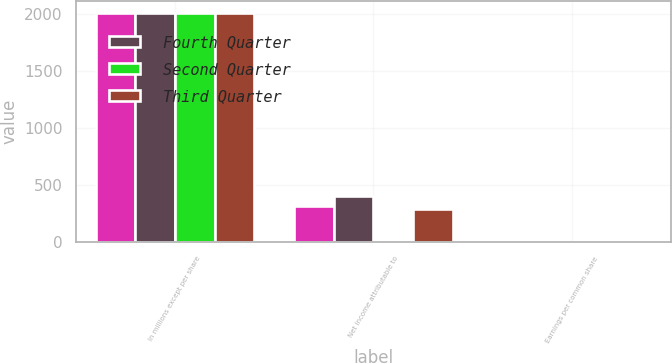<chart> <loc_0><loc_0><loc_500><loc_500><stacked_bar_chart><ecel><fcel>In millions except per share<fcel>Net income attributable to<fcel>Earnings per common share<nl><fcel>nan<fcel>2016<fcel>321<fcel>1.87<nl><fcel>Fourth Quarter<fcel>2016<fcel>406<fcel>2.4<nl><fcel>Second Quarter<fcel>2016<fcel>1<fcel>1<nl><fcel>Third Quarter<fcel>2016<fcel>289<fcel>1.72<nl></chart> 